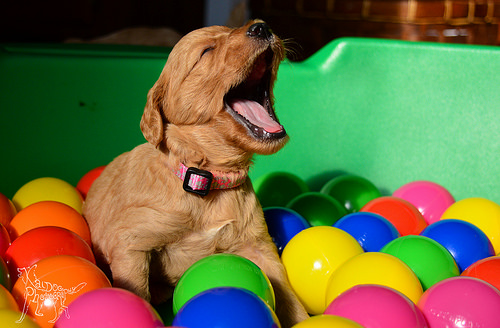<image>
Is the yellow ball under the puppy? No. The yellow ball is not positioned under the puppy. The vertical relationship between these objects is different. Is the puppy above the ball? Yes. The puppy is positioned above the ball in the vertical space, higher up in the scene. Is the dog in front of the ball? No. The dog is not in front of the ball. The spatial positioning shows a different relationship between these objects. 